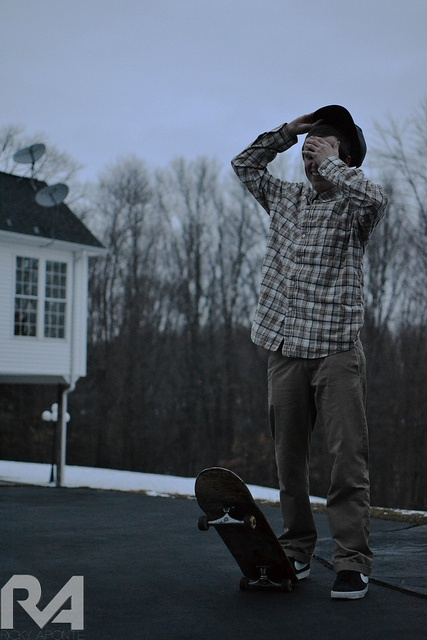Describe the objects in this image and their specific colors. I can see people in darkgray, black, and gray tones and skateboard in darkgray, black, gray, darkblue, and purple tones in this image. 